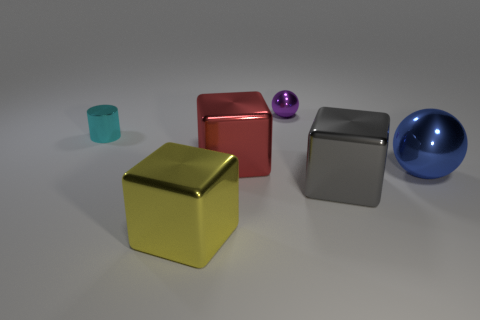The metallic cylinder has what color?
Ensure brevity in your answer.  Cyan. What number of cubes are in front of the cube that is behind the large metallic cube on the right side of the red block?
Your response must be concise. 2. What is the shape of the gray metal object?
Provide a succinct answer. Cube. How many blue things are the same material as the red thing?
Give a very brief answer. 1. What color is the other big ball that is made of the same material as the purple ball?
Keep it short and to the point. Blue. There is a blue object; is its size the same as the gray object on the right side of the big red cube?
Your answer should be very brief. Yes. How many objects are large cyan blocks or metal cubes?
Make the answer very short. 3. There is a purple thing that is the same size as the cyan metal cylinder; what shape is it?
Keep it short and to the point. Sphere. How many things are shiny things behind the tiny cyan cylinder or big things to the left of the tiny purple sphere?
Make the answer very short. 3. Is the number of matte spheres less than the number of purple metallic things?
Your answer should be compact. Yes. 